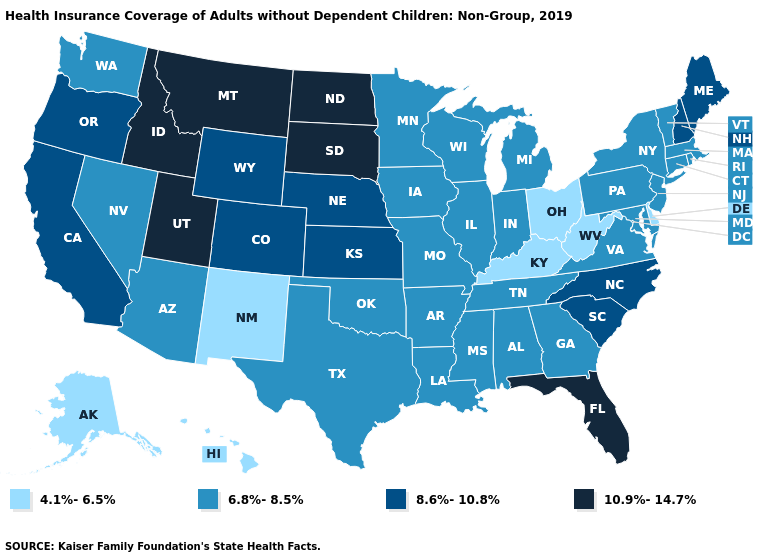What is the highest value in the West ?
Be succinct. 10.9%-14.7%. Does the map have missing data?
Be succinct. No. Among the states that border Utah , does Arizona have the highest value?
Answer briefly. No. What is the lowest value in states that border South Carolina?
Concise answer only. 6.8%-8.5%. How many symbols are there in the legend?
Quick response, please. 4. Name the states that have a value in the range 8.6%-10.8%?
Give a very brief answer. California, Colorado, Kansas, Maine, Nebraska, New Hampshire, North Carolina, Oregon, South Carolina, Wyoming. Name the states that have a value in the range 10.9%-14.7%?
Write a very short answer. Florida, Idaho, Montana, North Dakota, South Dakota, Utah. Name the states that have a value in the range 10.9%-14.7%?
Answer briefly. Florida, Idaho, Montana, North Dakota, South Dakota, Utah. Among the states that border South Carolina , which have the highest value?
Give a very brief answer. North Carolina. Name the states that have a value in the range 10.9%-14.7%?
Give a very brief answer. Florida, Idaho, Montana, North Dakota, South Dakota, Utah. What is the lowest value in states that border Rhode Island?
Answer briefly. 6.8%-8.5%. Which states hav the highest value in the South?
Write a very short answer. Florida. What is the lowest value in the USA?
Answer briefly. 4.1%-6.5%. Does Louisiana have a higher value than Utah?
Write a very short answer. No. What is the lowest value in states that border West Virginia?
Answer briefly. 4.1%-6.5%. 